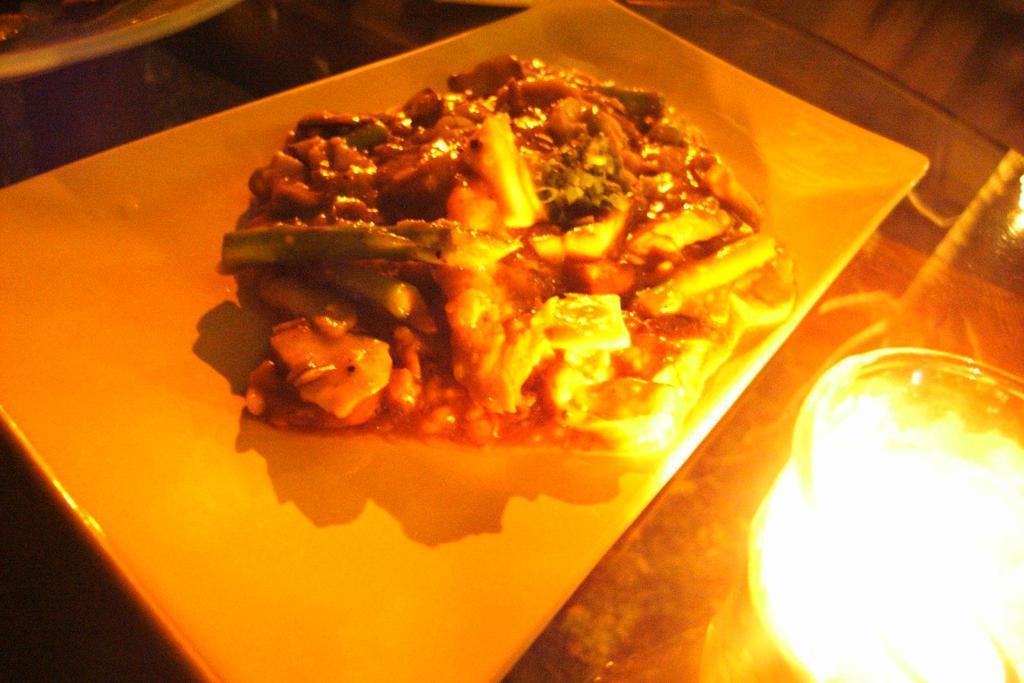Describe this image in one or two sentences. In this image, we can see food on the tray and in the background, we can see some objects on the table and there is a light. 